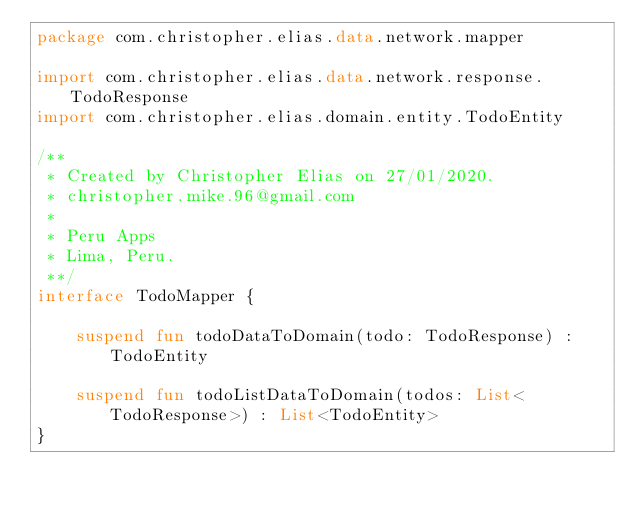Convert code to text. <code><loc_0><loc_0><loc_500><loc_500><_Kotlin_>package com.christopher.elias.data.network.mapper

import com.christopher.elias.data.network.response.TodoResponse
import com.christopher.elias.domain.entity.TodoEntity

/**
 * Created by Christopher Elias on 27/01/2020.
 * christopher.mike.96@gmail.com
 *
 * Peru Apps
 * Lima, Peru.
 **/
interface TodoMapper {

    suspend fun todoDataToDomain(todo: TodoResponse) : TodoEntity

    suspend fun todoListDataToDomain(todos: List<TodoResponse>) : List<TodoEntity>
}</code> 